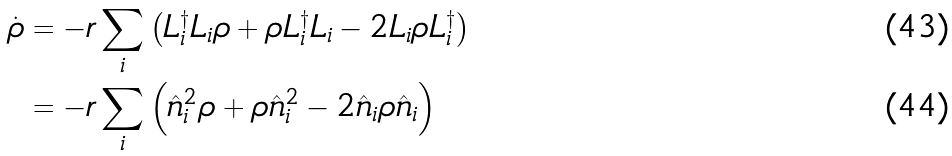Convert formula to latex. <formula><loc_0><loc_0><loc_500><loc_500>\dot { \rho } & = - r \sum _ { i } \left ( L _ { i } ^ { \dagger } L _ { i } \rho + \rho L _ { i } ^ { \dagger } L _ { i } - 2 L _ { i } \rho L _ { i } ^ { \dagger } \right ) \\ & = - r \sum _ { i } \left ( \hat { n } _ { i } ^ { 2 } \rho + \rho \hat { n } _ { i } ^ { 2 } - 2 \hat { n } _ { i } \rho \hat { n } _ { i } \right )</formula> 